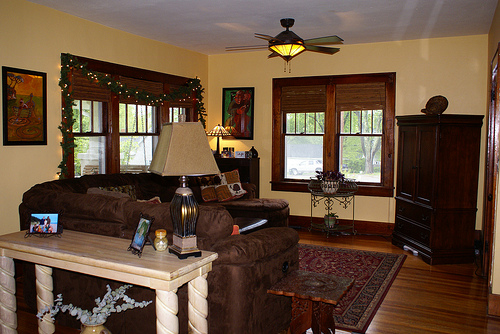Please provide a short description for this region: [0.44, 0.34, 0.51, 0.45]. A vibrant painting hanging on the wall. 